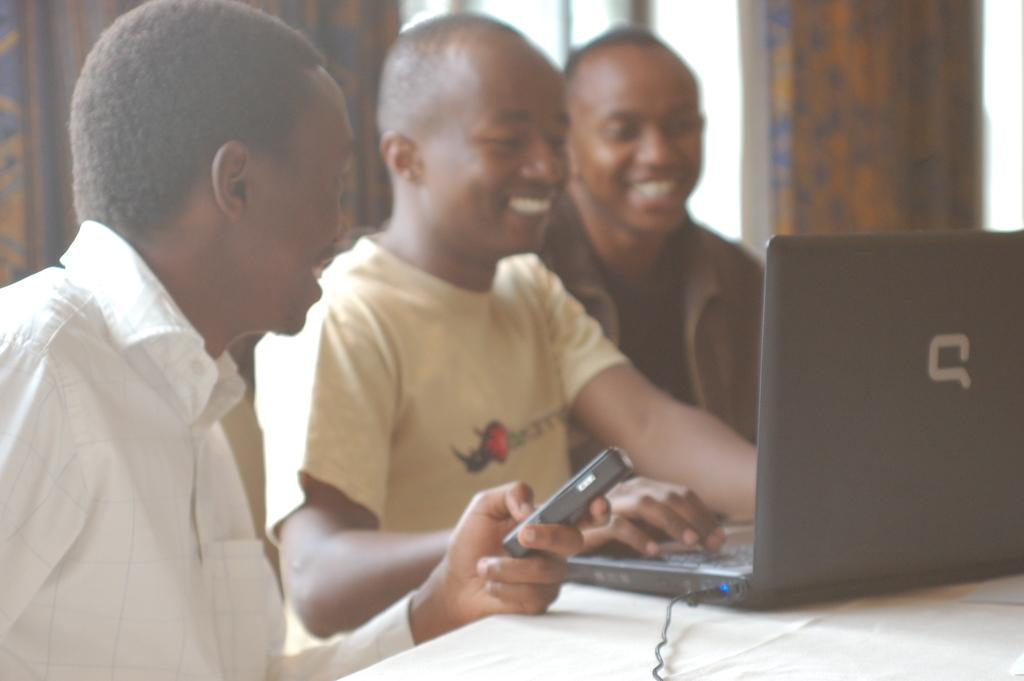How many people are in the image? There are three men in the image. What are the men doing in the image? The men are sitting and smiling. What object is in front of the men? There is a laptop in front of the men. Is one of the men using a device in the image? Yes, one man is holding a cellphone. What type of pets can be seen playing with the men in the image? There are no pets present in the image; it only features the three men and the objects mentioned. 